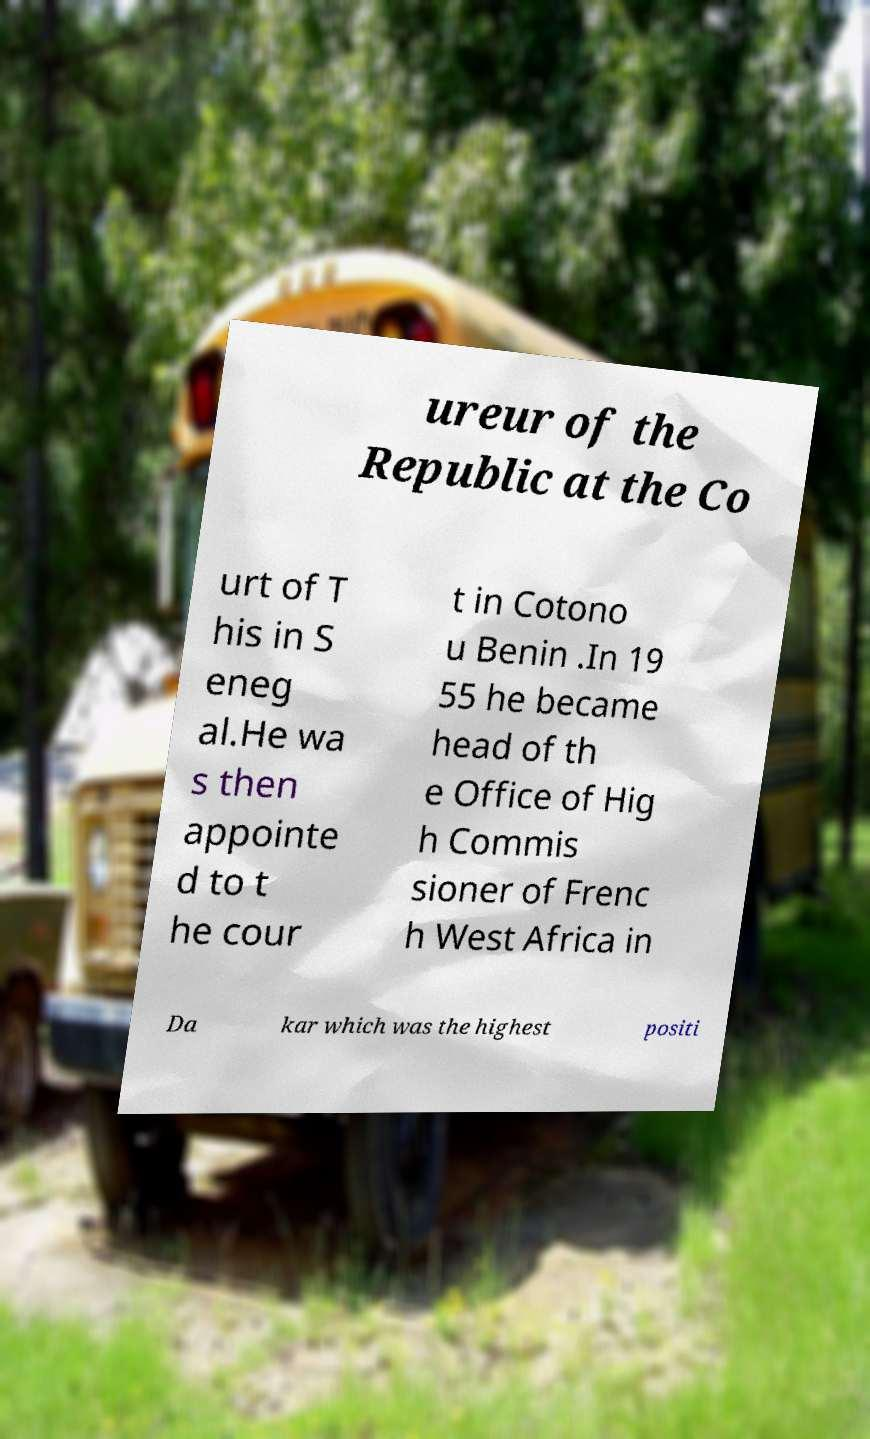Please identify and transcribe the text found in this image. ureur of the Republic at the Co urt of T his in S eneg al.He wa s then appointe d to t he cour t in Cotono u Benin .In 19 55 he became head of th e Office of Hig h Commis sioner of Frenc h West Africa in Da kar which was the highest positi 